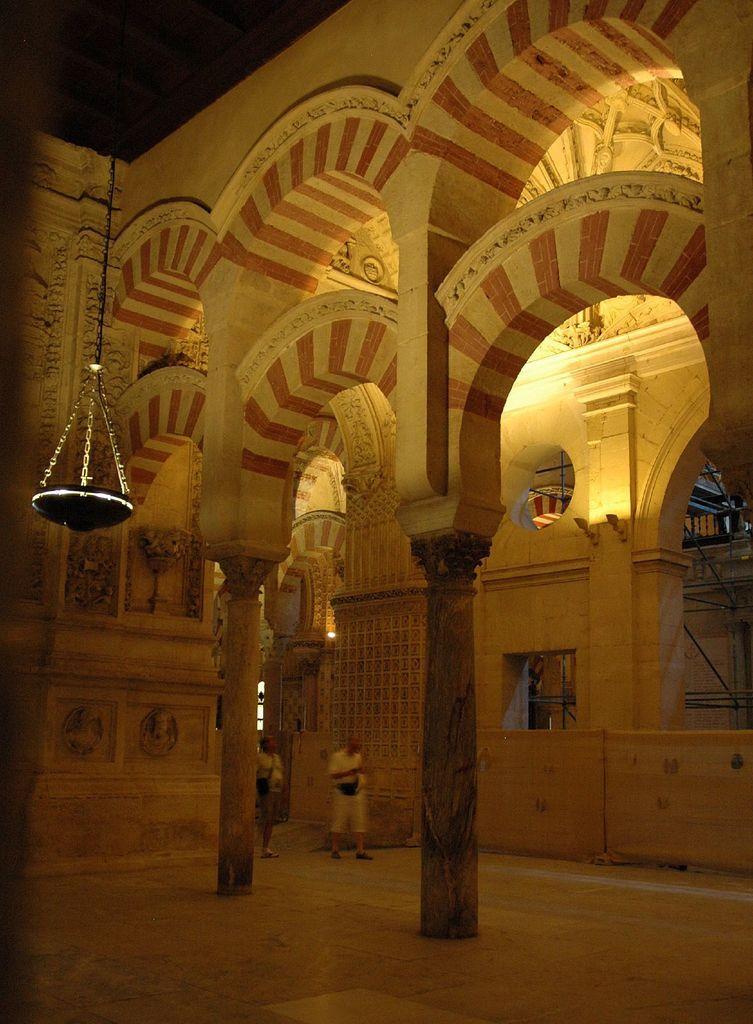Describe this image in one or two sentences. In the middle of the image there is a building, in the building two persons are standing. 